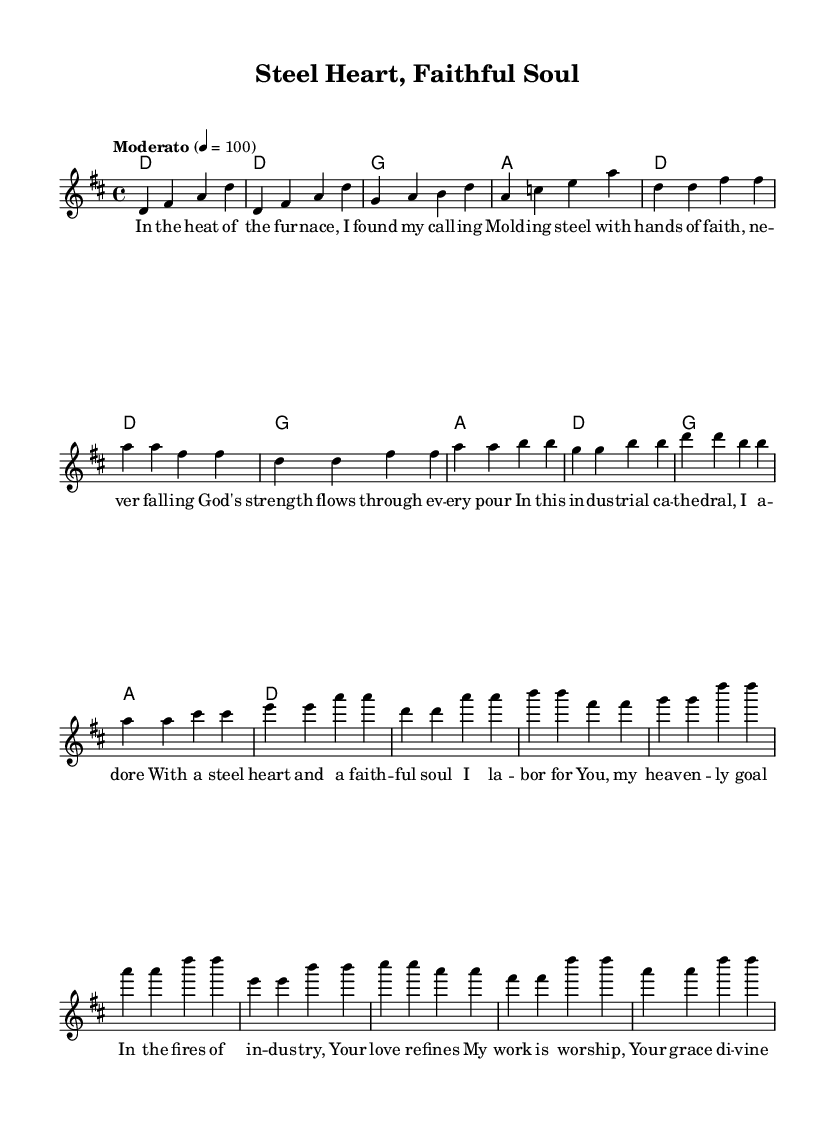What is the key signature of this music? The key signature is indicated at the beginning of the sheet music and is D major, which has two sharps (F# and C#).
Answer: D major What is the time signature of this piece? The time signature is located at the beginning of the staff and is represented as 4/4, meaning there are four beats per measure and the quarter note gets one beat.
Answer: 4/4 What is the tempo marking for this song? The tempo marking is written above the staff and indicates a speed of moderato, with a metronome marking of 100 beats per minute.
Answer: Moderato, 100 What is the first lyric of Verse One? The first lyric is found in the lyric section corresponding to the melody and reads: "In the heat of the fur -- nace."
Answer: In the heat of the furnace How many measures are in the Chorus section? Counting the measures in the Chorus from the provided music, there are four distinct measures containing musical notes.
Answer: 4 What do the lyrics of the chorus celebrate? The chorus lyrics express a celebration of labor and devotion to God, emphasizing that work is a form of worship influenced by divine grace.
Answer: Labor and devotion to God Which industrial metaphor is used in this song? The song uses the metaphor of a "steel heart" to describe resilience and faith, connecting the experience of industrial work to spiritual strength.
Answer: Steel heart 